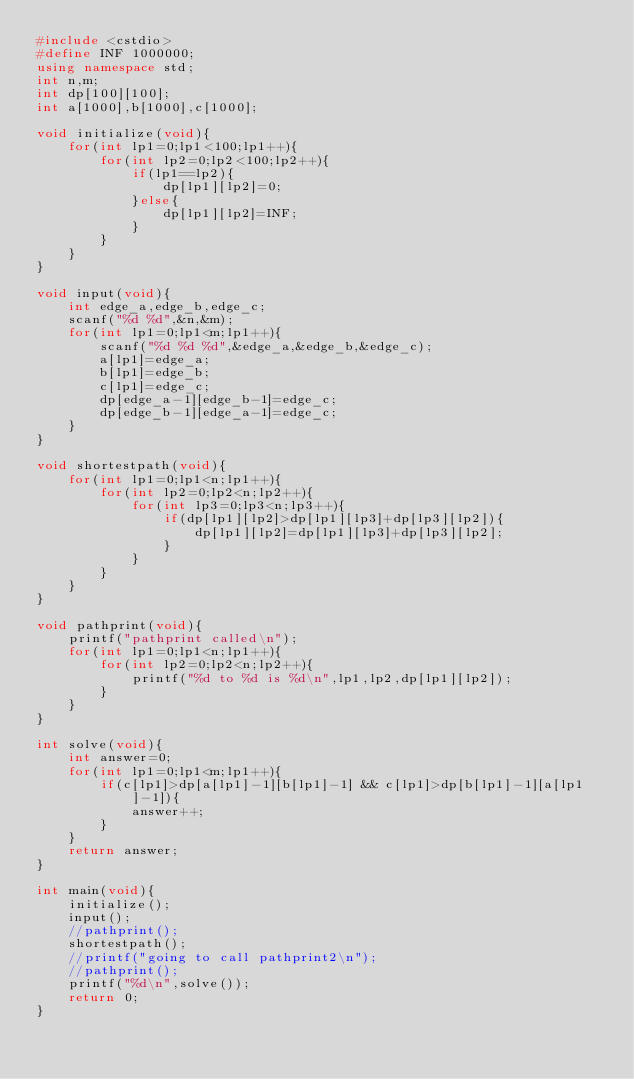Convert code to text. <code><loc_0><loc_0><loc_500><loc_500><_C++_>#include <cstdio>
#define INF 1000000;
using namespace std;
int n,m;
int dp[100][100];
int a[1000],b[1000],c[1000];

void initialize(void){
	for(int lp1=0;lp1<100;lp1++){
		for(int lp2=0;lp2<100;lp2++){
			if(lp1==lp2){
				dp[lp1][lp2]=0;
			}else{
				dp[lp1][lp2]=INF;
			}
		}
	}
}

void input(void){
	int edge_a,edge_b,edge_c;
	scanf("%d %d",&n,&m);
	for(int lp1=0;lp1<m;lp1++){
		scanf("%d %d %d",&edge_a,&edge_b,&edge_c);
		a[lp1]=edge_a;
		b[lp1]=edge_b;
		c[lp1]=edge_c;
		dp[edge_a-1][edge_b-1]=edge_c;
		dp[edge_b-1][edge_a-1]=edge_c;
	}
}

void shortestpath(void){
	for(int lp1=0;lp1<n;lp1++){
		for(int lp2=0;lp2<n;lp2++){
			for(int lp3=0;lp3<n;lp3++){
				if(dp[lp1][lp2]>dp[lp1][lp3]+dp[lp3][lp2]){
					dp[lp1][lp2]=dp[lp1][lp3]+dp[lp3][lp2];
				}
			}
		}
	}
} 

void pathprint(void){
	printf("pathprint called\n");
	for(int lp1=0;lp1<n;lp1++){
		for(int lp2=0;lp2<n;lp2++){
			printf("%d to %d is %d\n",lp1,lp2,dp[lp1][lp2]);
		}
	}
}

int solve(void){
	int answer=0;
	for(int lp1=0;lp1<m;lp1++){
		if(c[lp1]>dp[a[lp1]-1][b[lp1]-1] && c[lp1]>dp[b[lp1]-1][a[lp1]-1]){
			answer++;
		}
	}
	return answer;
}

int main(void){
	initialize();
	input();
	//pathprint();
	shortestpath();
	//printf("going to call pathprint2\n");
	//pathprint();
	printf("%d\n",solve());
	return 0;
}
	
</code> 